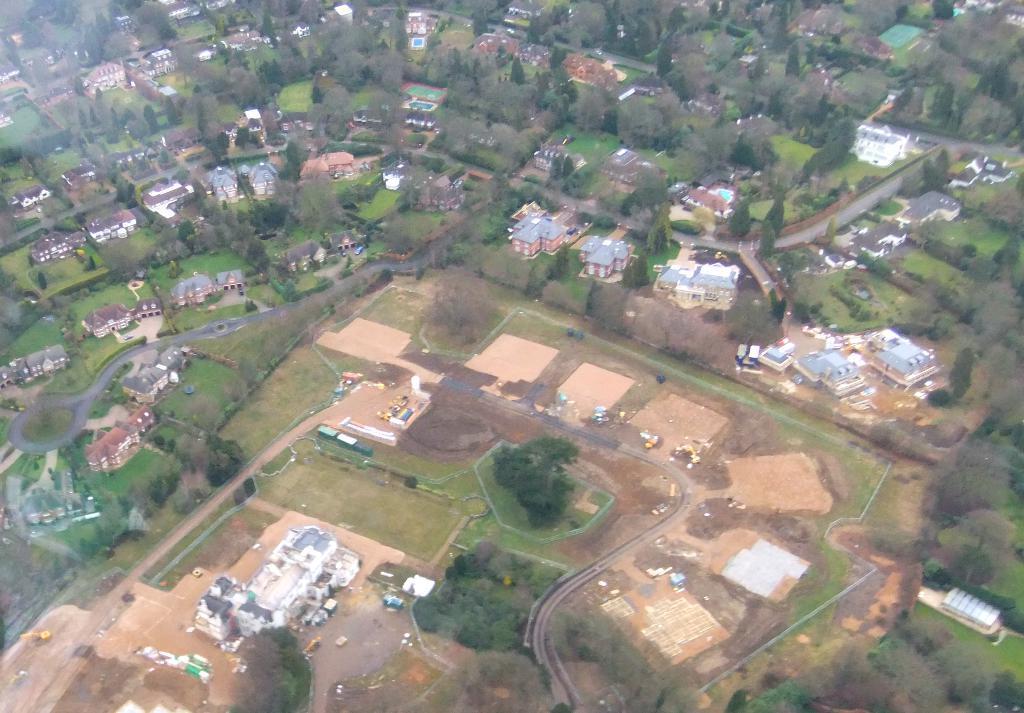Describe this image in one or two sentences. In this picture we can see roads, buildings, trees. 